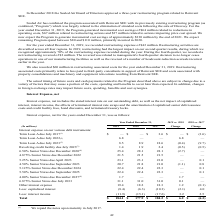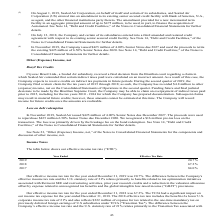According to Sealed Air Corporation's financial document, What does the table show? Interest expense, net for the years ended December 31. The document states: "Interest expense, net for the years ended December 31, was as follows:..." Also, What does Interest expense, net include? Interest expense, net includes the stated interest rate on our outstanding debt, as well as the net impact of capitalized interest, interest income, the effects of terminated interest rate swaps and the amortization of capitalized senior debt issuance costs and credit facility fees, bond discounts, and terminated treasury locks.. The document states: "Interest expense, net includes the stated interest rate on our outstanding debt, as well as the net impact of capitalized interest, interest income, t..." Also, In In November 2019, what were the proceeds of issuing $425 million of 4.00% Senior Notes due 2027 used for? retire the existing $425 million of 6.50% Senior Notes due 2020.. The document states: "00% Senior Notes due 2027 and used the proceeds to retire the existing $425 million of 6.50% Senior Notes due 2020. See Note 14, "Debt and Credit Faci..." Also, can you calculate: What is the Total interest expense for years 2017-2019? Based on the calculation: 184.1+177.9+184.2, the result is 546.2 (in millions). This is based on the information: "Total $ 184.1 $ 177.9 $ 184.2 $ 6.2 $ (6.3) Total $ 184.1 $ 177.9 $ 184.2 $ 6.2 $ (6.3) Total $ 184.1 $ 177.9 $ 184.2 $ 6.2 $ (6.3)..." The key data points involved are: 177.9, 184.1, 184.2. Also, can you calculate: For the year 2019, what is the interest expense for Senior Notes due from 2020-2023 inclusive? Based on the calculation: 25.4+21.5+23.1+20.7, the result is 90.7 (in millions). This is based on the information: "4.875% Senior Notes due December 2022 21.5 21.5 21.5 — — 5) (0.5) 6.50% Senior Notes due December 2020 (4) 25.4 28.1 28.1 (2.7) — 4.50% Senior Notes due September 2023 20.7 21.8 21.0 (1.1) 0.8 5.25% S..." The key data points involved are: 20.7, 21.5, 23.1. Also, can you calculate: What is the change of the percentage change of Total interest expense from 2018 vs. 2017 to 2019 vs. 2018? To answer this question, I need to perform calculations using the financial data. The calculation is: (184.1-177.9)/177.9-(177.9-184.2)/184.2, which equals 6.91 (percentage). This is based on the information: "Total $ 184.1 $ 177.9 $ 184.2 $ 6.2 $ (6.3) Total $ 184.1 $ 177.9 $ 184.2 $ 6.2 $ (6.3) Total $ 184.1 $ 177.9 $ 184.2 $ 6.2 $ (6.3)..." The key data points involved are: 177.9, 184.1, 184.2. 